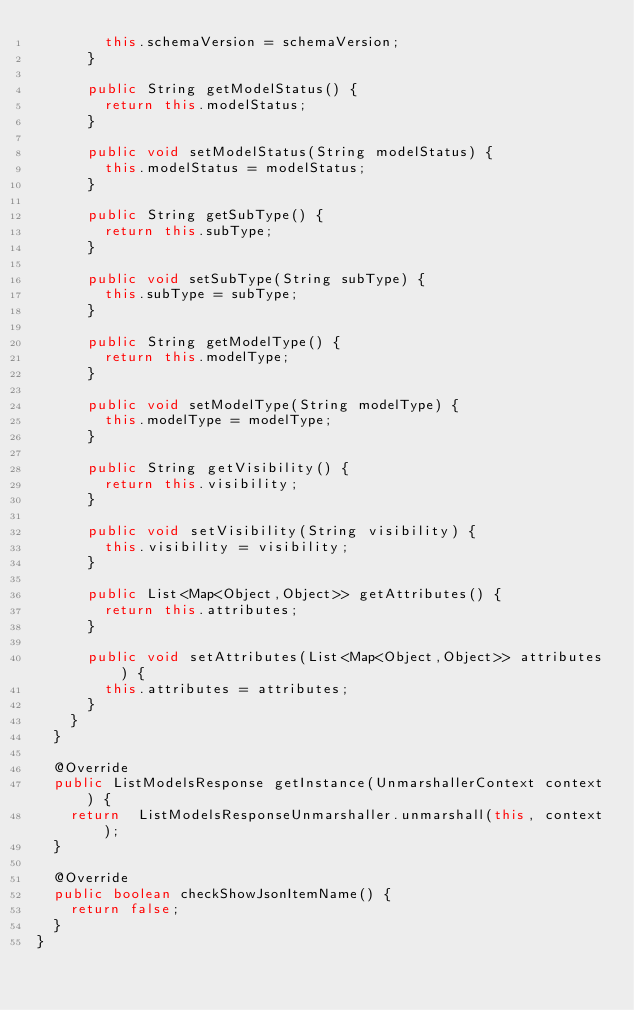<code> <loc_0><loc_0><loc_500><loc_500><_Java_>				this.schemaVersion = schemaVersion;
			}

			public String getModelStatus() {
				return this.modelStatus;
			}

			public void setModelStatus(String modelStatus) {
				this.modelStatus = modelStatus;
			}

			public String getSubType() {
				return this.subType;
			}

			public void setSubType(String subType) {
				this.subType = subType;
			}

			public String getModelType() {
				return this.modelType;
			}

			public void setModelType(String modelType) {
				this.modelType = modelType;
			}

			public String getVisibility() {
				return this.visibility;
			}

			public void setVisibility(String visibility) {
				this.visibility = visibility;
			}

			public List<Map<Object,Object>> getAttributes() {
				return this.attributes;
			}

			public void setAttributes(List<Map<Object,Object>> attributes) {
				this.attributes = attributes;
			}
		}
	}

	@Override
	public ListModelsResponse getInstance(UnmarshallerContext context) {
		return	ListModelsResponseUnmarshaller.unmarshall(this, context);
	}

	@Override
	public boolean checkShowJsonItemName() {
		return false;
	}
}
</code> 